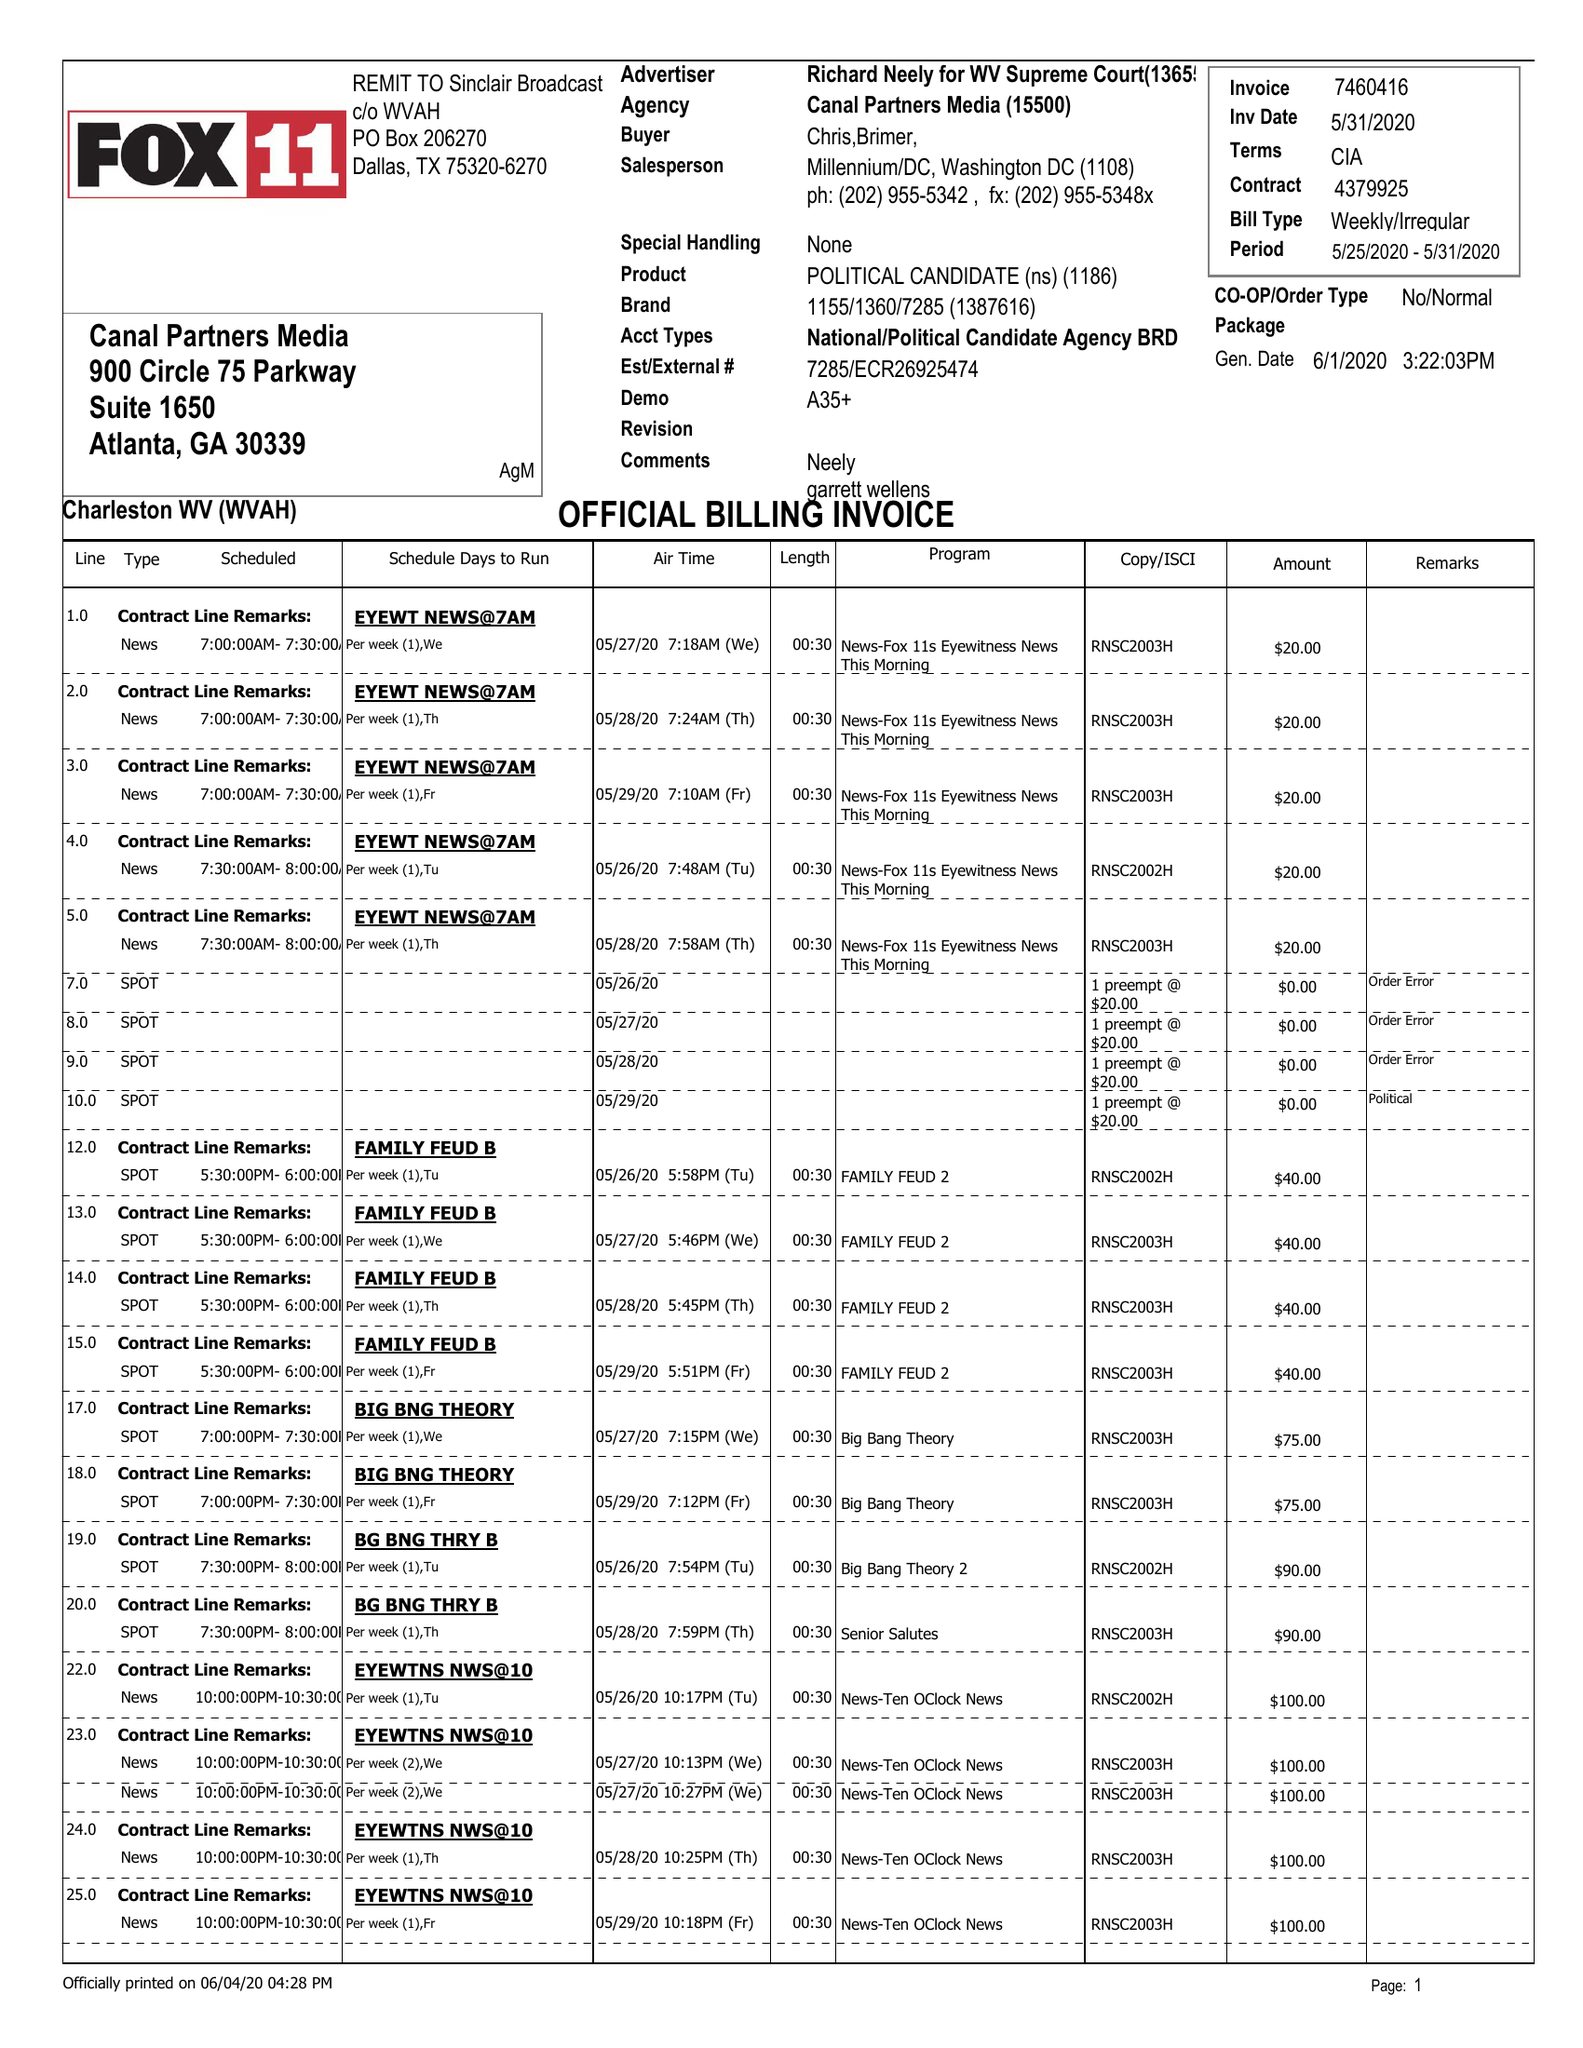What is the value for the flight_from?
Answer the question using a single word or phrase. 05/25/20 